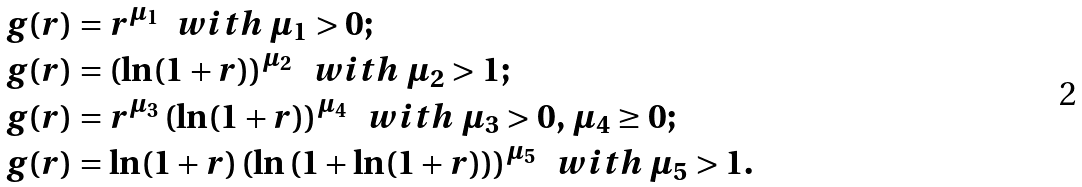<formula> <loc_0><loc_0><loc_500><loc_500>& g ( r ) = r ^ { \mu _ { 1 } } \ \ w i t h \ \mu _ { 1 } > 0 ; \\ & g ( r ) = \left ( \ln ( 1 + r ) \right ) ^ { \mu _ { 2 } } \ \ w i t h \ \mu _ { 2 } > 1 ; \\ & g ( r ) = r ^ { \mu _ { 3 } } \left ( \ln ( 1 + r ) \right ) ^ { \mu _ { 4 } } \ \ w i t h \ \mu _ { 3 } > 0 , \, \mu _ { 4 } \geq 0 ; \\ & g ( r ) = \ln ( 1 + r ) \left ( \ln \left ( 1 + \ln ( 1 + r ) \right ) \right ) ^ { \mu _ { 5 } } \ \ w i t h \ \mu _ { 5 } > 1 .</formula> 